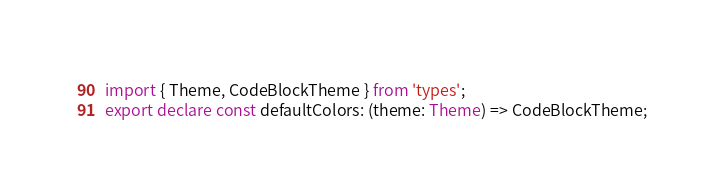Convert code to text. <code><loc_0><loc_0><loc_500><loc_500><_TypeScript_>import { Theme, CodeBlockTheme } from 'types';
export declare const defaultColors: (theme: Theme) => CodeBlockTheme;
</code> 